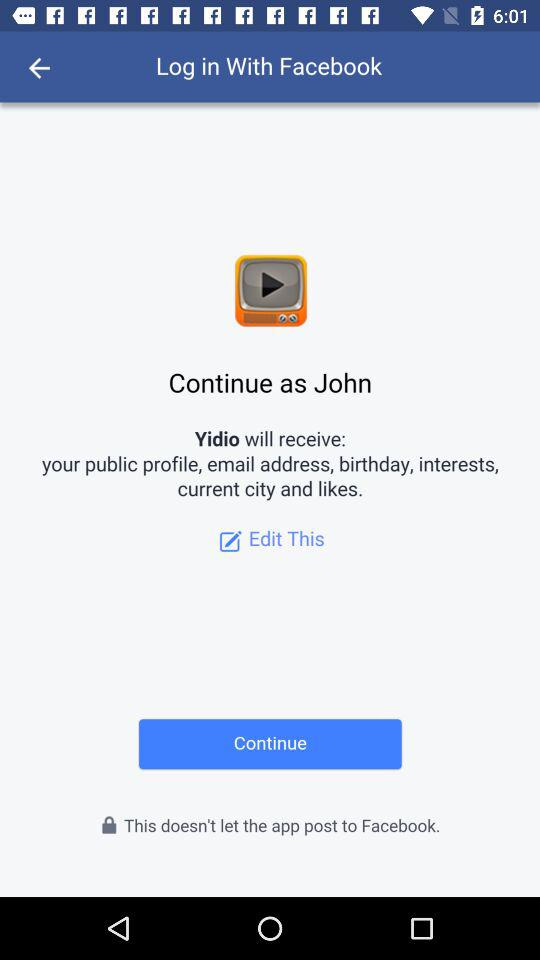What is the information to be accessed? The information to be accessed is the public profile, email address, birthday, interests, current city and likes. 